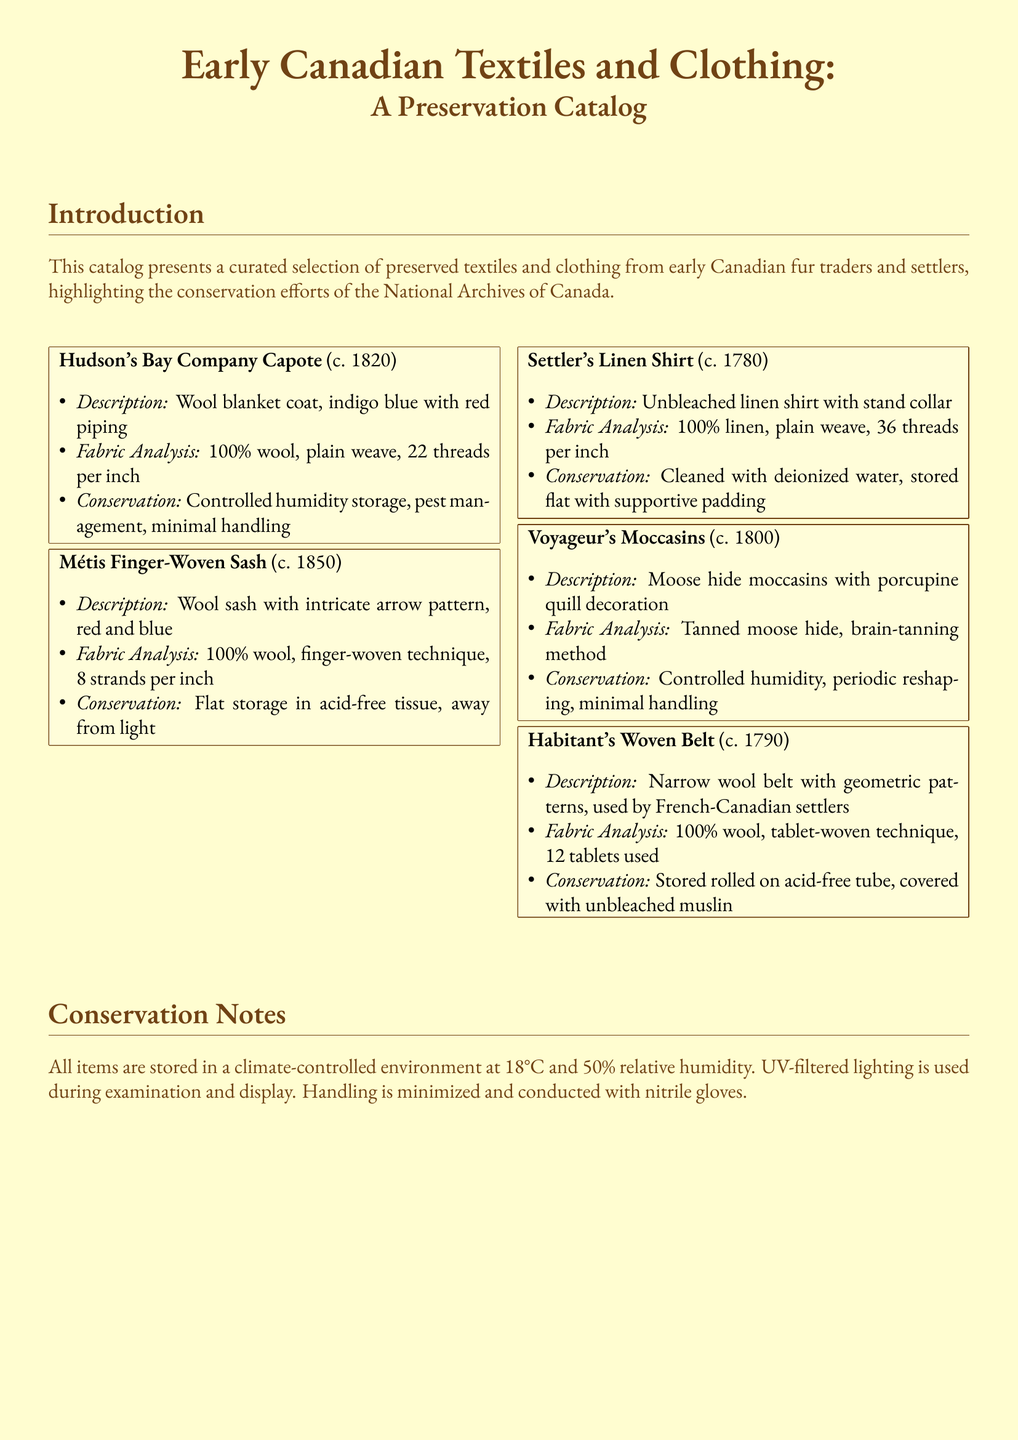What is the title of the catalog? The title provides an overview of the content, which is "Early Canadian Textiles and Clothing: A Preservation Catalog."
Answer: Early Canadian Textiles and Clothing: A Preservation Catalog What is the earliest date of the items listed? The earliest item in the catalog is the Settler's Linen Shirt, dated around 1780.
Answer: c. 1780 Which company is associated with the Capote? The Capote is attributed to the historical Hudson's Bay Company.
Answer: Hudson's Bay Company What material is the Métis Finger-Woven Sash made from? The sash is specified to be made of 100% wool.
Answer: 100% wool What conservation method is used for the Voyageur's Moccasins? The moccasins are stored with controlled humidity, among other methods.
Answer: Controlled humidity How many threads per inch does the Settler's Linen Shirt have? The shirt features a dense weave with 36 threads per inch.
Answer: 36 threads per inch What color is the Hudson's Bay Company Capote? The Capote is described as indigo blue with red piping.
Answer: indigo blue with red piping What type of decoration is found on the Voyageur's Moccasins? The moccasins feature porcupine quill decoration.
Answer: porcupine quill decoration What is the specific storage material for the Habitant's Woven Belt? The belt is stored rolled on an acid-free tube covered with unbleached muslin.
Answer: unbleached muslin 